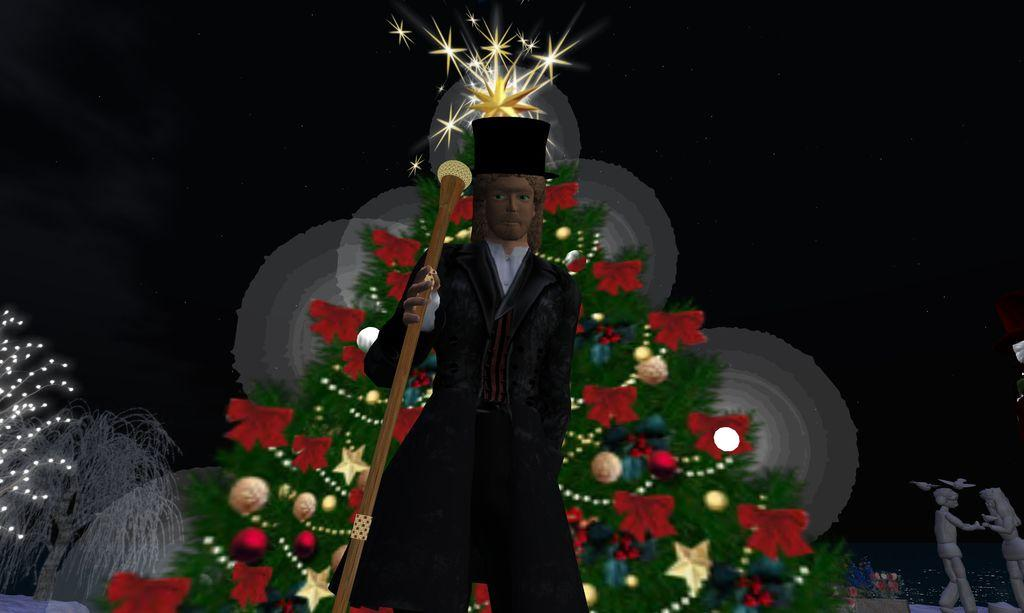What is the main subject of the image? There is a sculpture of a man in the image. What is located behind the sculpture? There is a Christmas tree behind the sculpture. What other objects can be seen on the right side of the image? There are two toys on the right side of the image. Can you tell if any editing has been done to the image? Yes, the image appears to have been edited. What type of goat can be seen climbing the sculpture in the image? There is no goat present in the image; it features a sculpture of a man and a Christmas tree. How many trees are depicted in the image? The image only shows one tree, which is a Christmas tree located behind the sculpture. 